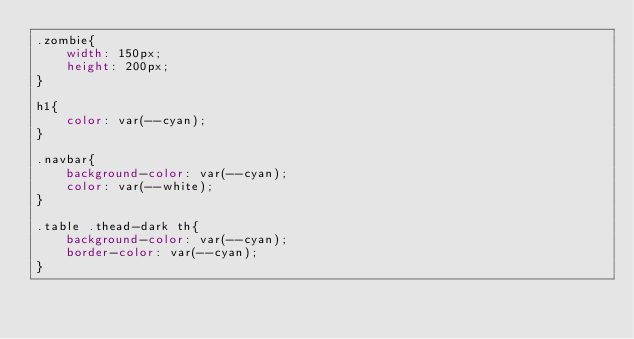Convert code to text. <code><loc_0><loc_0><loc_500><loc_500><_CSS_>.zombie{
    width: 150px;
    height: 200px;
}

h1{
    color: var(--cyan);
}

.navbar{
    background-color: var(--cyan);
    color: var(--white);
}

.table .thead-dark th{
    background-color: var(--cyan);
    border-color: var(--cyan);
}</code> 